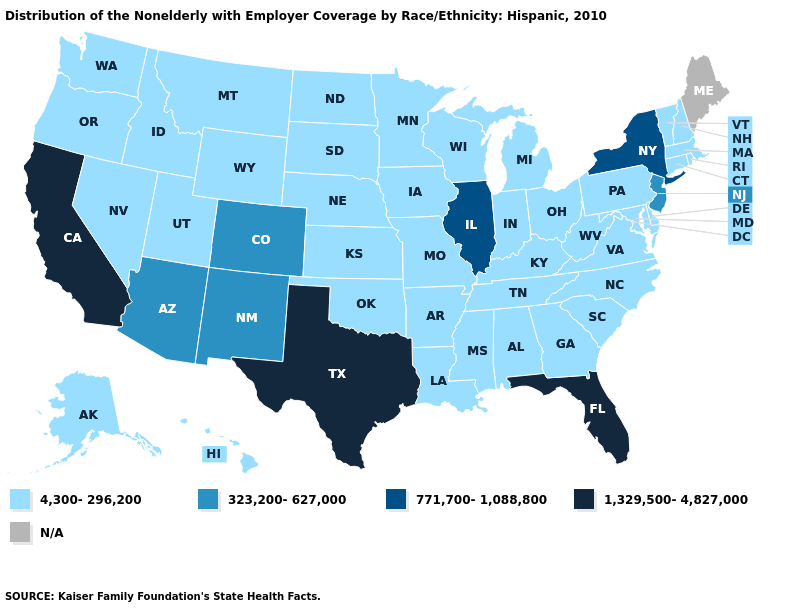Which states have the highest value in the USA?
Short answer required. California, Florida, Texas. Among the states that border Wyoming , which have the lowest value?
Give a very brief answer. Idaho, Montana, Nebraska, South Dakota, Utah. Name the states that have a value in the range 4,300-296,200?
Short answer required. Alabama, Alaska, Arkansas, Connecticut, Delaware, Georgia, Hawaii, Idaho, Indiana, Iowa, Kansas, Kentucky, Louisiana, Maryland, Massachusetts, Michigan, Minnesota, Mississippi, Missouri, Montana, Nebraska, Nevada, New Hampshire, North Carolina, North Dakota, Ohio, Oklahoma, Oregon, Pennsylvania, Rhode Island, South Carolina, South Dakota, Tennessee, Utah, Vermont, Virginia, Washington, West Virginia, Wisconsin, Wyoming. Name the states that have a value in the range N/A?
Be succinct. Maine. What is the value of Alabama?
Write a very short answer. 4,300-296,200. Does the first symbol in the legend represent the smallest category?
Keep it brief. Yes. What is the lowest value in states that border North Carolina?
Answer briefly. 4,300-296,200. Which states have the lowest value in the West?
Keep it brief. Alaska, Hawaii, Idaho, Montana, Nevada, Oregon, Utah, Washington, Wyoming. How many symbols are there in the legend?
Write a very short answer. 5. What is the value of Georgia?
Give a very brief answer. 4,300-296,200. What is the value of New Hampshire?
Give a very brief answer. 4,300-296,200. Which states have the lowest value in the MidWest?
Be succinct. Indiana, Iowa, Kansas, Michigan, Minnesota, Missouri, Nebraska, North Dakota, Ohio, South Dakota, Wisconsin. 